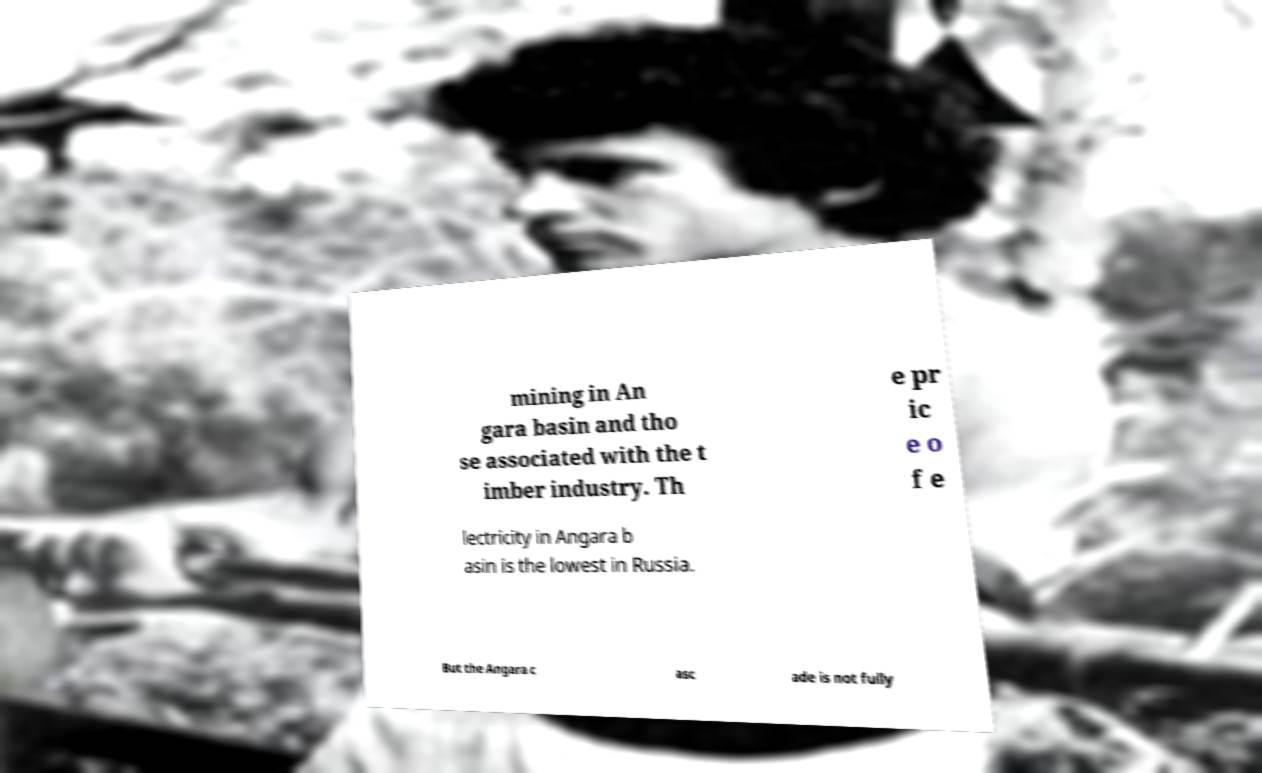Could you extract and type out the text from this image? mining in An gara basin and tho se associated with the t imber industry. Th e pr ic e o f e lectricity in Angara b asin is the lowest in Russia. But the Angara c asc ade is not fully 